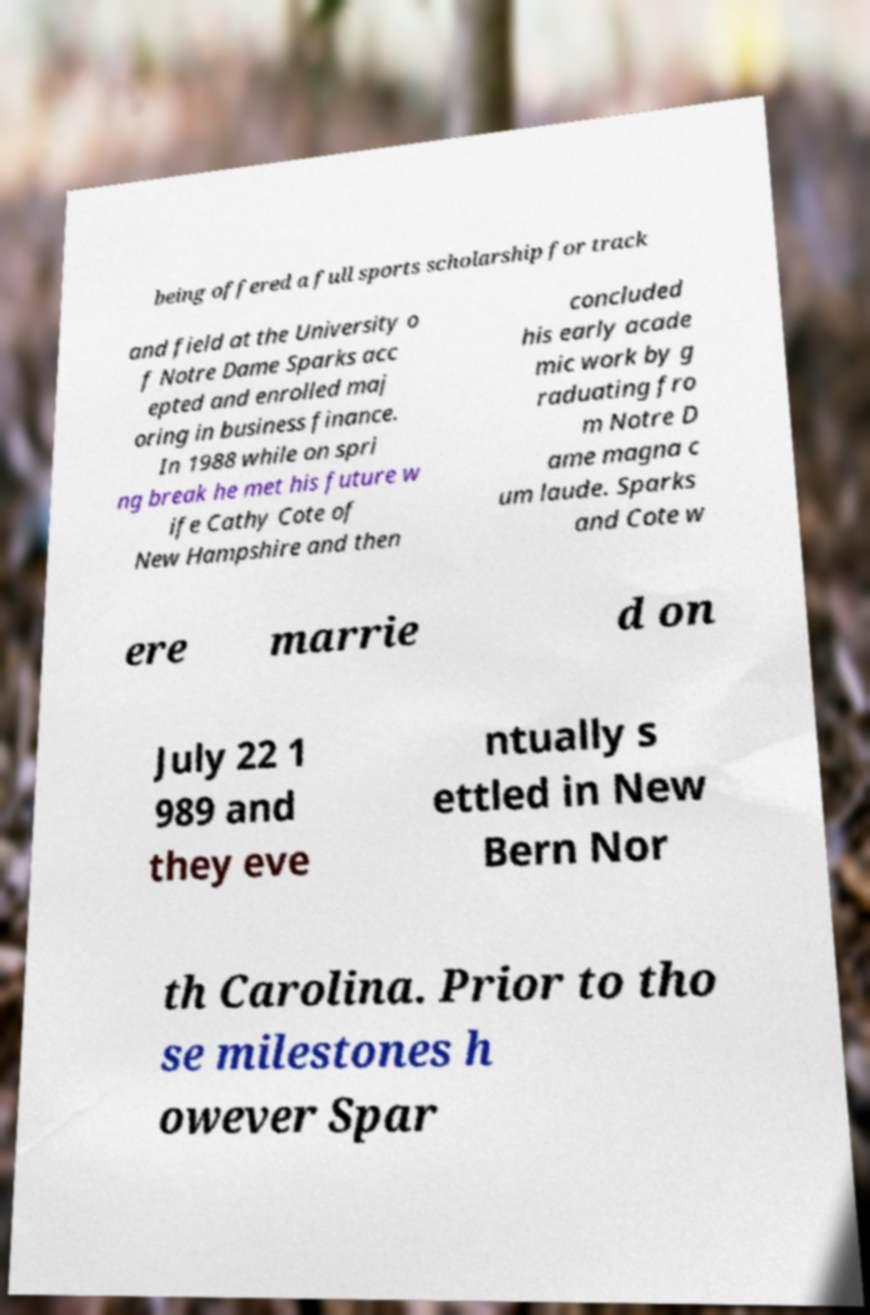I need the written content from this picture converted into text. Can you do that? being offered a full sports scholarship for track and field at the University o f Notre Dame Sparks acc epted and enrolled maj oring in business finance. In 1988 while on spri ng break he met his future w ife Cathy Cote of New Hampshire and then concluded his early acade mic work by g raduating fro m Notre D ame magna c um laude. Sparks and Cote w ere marrie d on July 22 1 989 and they eve ntually s ettled in New Bern Nor th Carolina. Prior to tho se milestones h owever Spar 